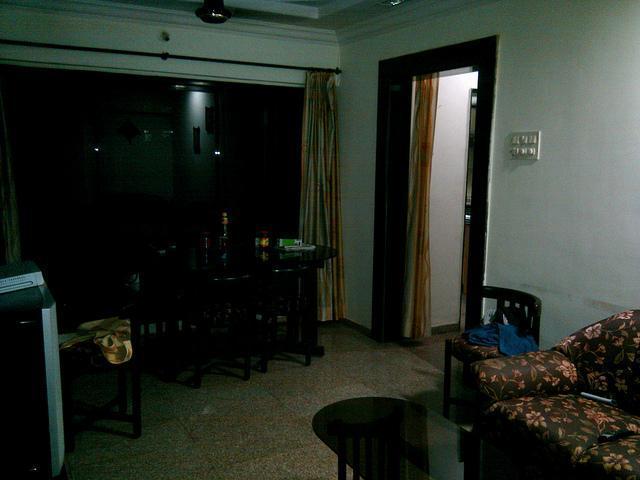How many chairs are there?
Give a very brief answer. 3. How many bikes in the image?
Give a very brief answer. 0. 